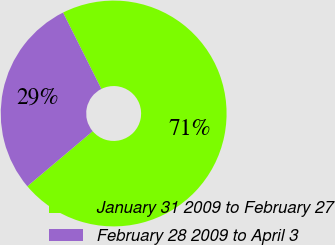Convert chart to OTSL. <chart><loc_0><loc_0><loc_500><loc_500><pie_chart><fcel>January 31 2009 to February 27<fcel>February 28 2009 to April 3<nl><fcel>71.25%<fcel>28.75%<nl></chart> 